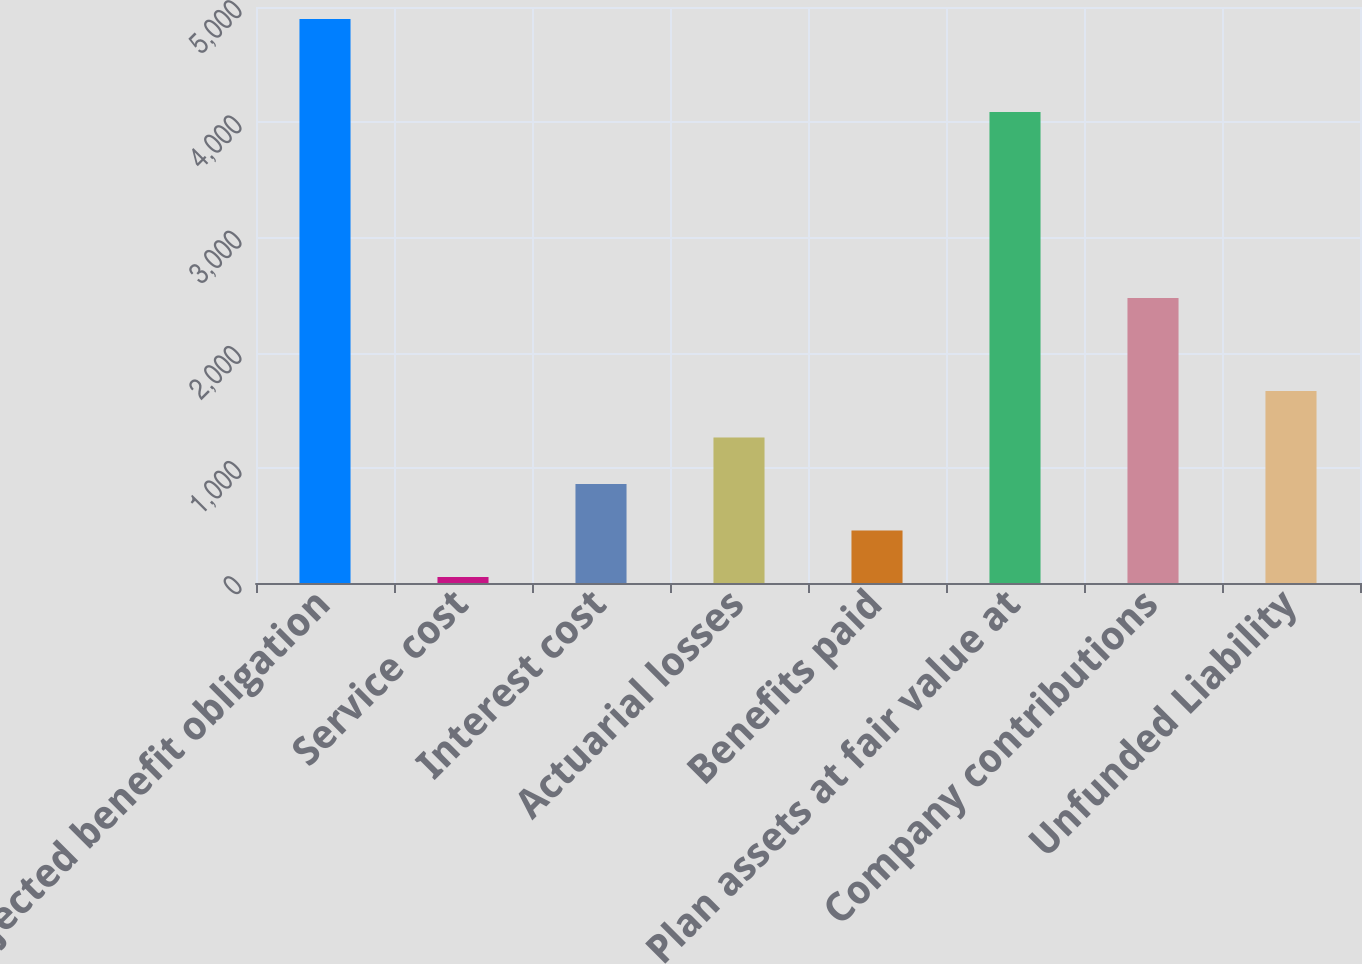Convert chart. <chart><loc_0><loc_0><loc_500><loc_500><bar_chart><fcel>Projected benefit obligation<fcel>Service cost<fcel>Interest cost<fcel>Actuarial losses<fcel>Benefits paid<fcel>Plan assets at fair value at<fcel>Company contributions<fcel>Unfunded Liability<nl><fcel>4895.4<fcel>51<fcel>858.4<fcel>1262.1<fcel>454.7<fcel>4088<fcel>2473.2<fcel>1665.8<nl></chart> 